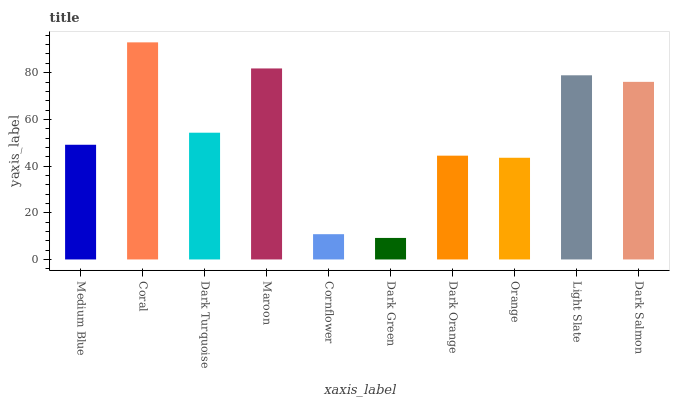Is Dark Green the minimum?
Answer yes or no. Yes. Is Coral the maximum?
Answer yes or no. Yes. Is Dark Turquoise the minimum?
Answer yes or no. No. Is Dark Turquoise the maximum?
Answer yes or no. No. Is Coral greater than Dark Turquoise?
Answer yes or no. Yes. Is Dark Turquoise less than Coral?
Answer yes or no. Yes. Is Dark Turquoise greater than Coral?
Answer yes or no. No. Is Coral less than Dark Turquoise?
Answer yes or no. No. Is Dark Turquoise the high median?
Answer yes or no. Yes. Is Medium Blue the low median?
Answer yes or no. Yes. Is Maroon the high median?
Answer yes or no. No. Is Orange the low median?
Answer yes or no. No. 